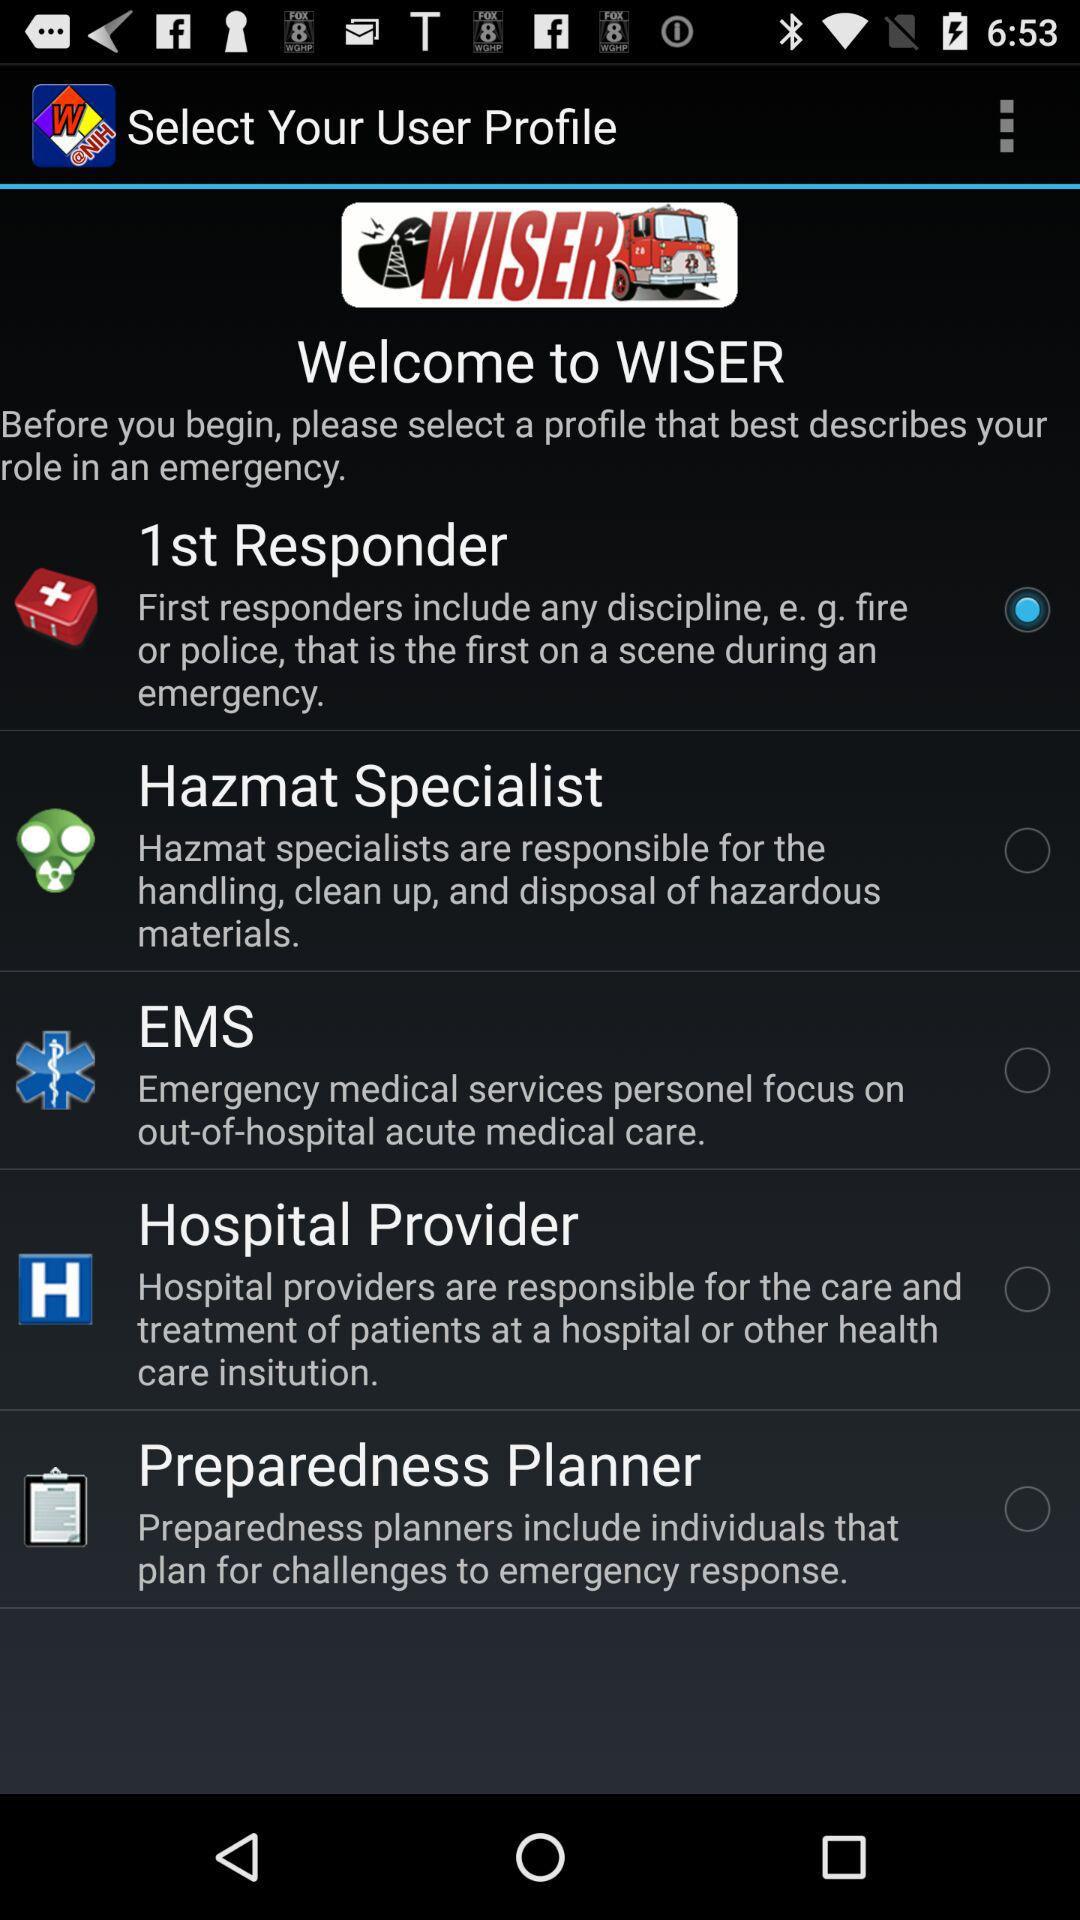Is "Hospital Provider" selected or not? "Hospital Provider" is not selected. 